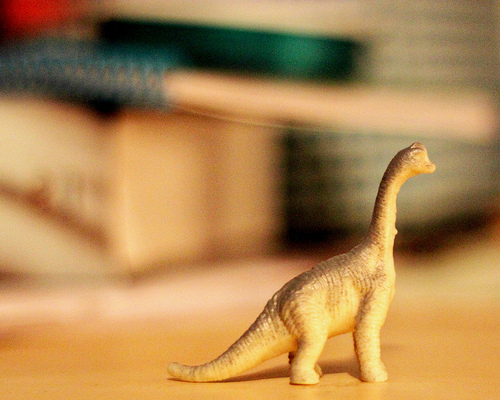<image>
Is there a dinosaur on the table? Yes. Looking at the image, I can see the dinosaur is positioned on top of the table, with the table providing support. 